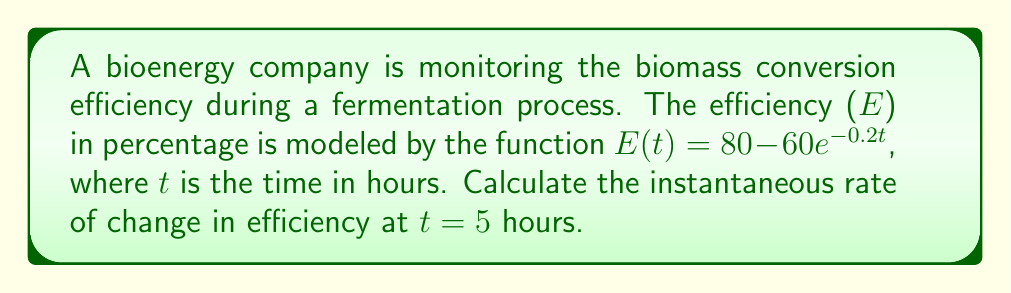Help me with this question. To find the instantaneous rate of change in efficiency at t = 5 hours, we need to calculate the derivative of the function E(t) and evaluate it at t = 5.

1) The given function is $E(t) = 80 - 60e^{-0.2t}$

2) To find the derivative, we use the chain rule:
   $$\frac{dE}{dt} = -60 \cdot (-0.2)e^{-0.2t} = 12e^{-0.2t}$$

3) Now we evaluate this derivative at t = 5:
   $$\frac{dE}{dt}\bigg|_{t=5} = 12e^{-0.2(5)}$$

4) Simplify:
   $$12e^{-1} = \frac{12}{e} \approx 4.4158$$

5) Interpret the result: The instantaneous rate of change in efficiency at t = 5 hours is approximately 4.4158% per hour.
Answer: The instantaneous rate of change in biomass conversion efficiency at t = 5 hours is approximately 4.4158% per hour. 